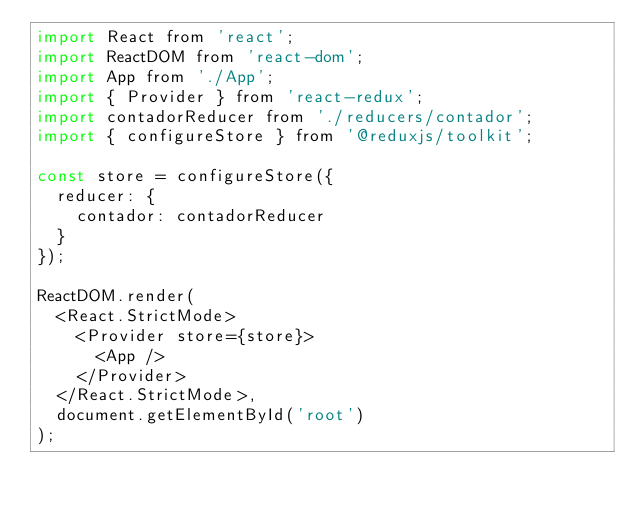Convert code to text. <code><loc_0><loc_0><loc_500><loc_500><_JavaScript_>import React from 'react';
import ReactDOM from 'react-dom';
import App from './App';
import { Provider } from 'react-redux';
import contadorReducer from './reducers/contador';
import { configureStore } from '@reduxjs/toolkit';

const store = configureStore({
  reducer: {
    contador: contadorReducer
  }
});

ReactDOM.render(
  <React.StrictMode>
    <Provider store={store}>
      <App />
    </Provider>
  </React.StrictMode>,
  document.getElementById('root')
);</code> 